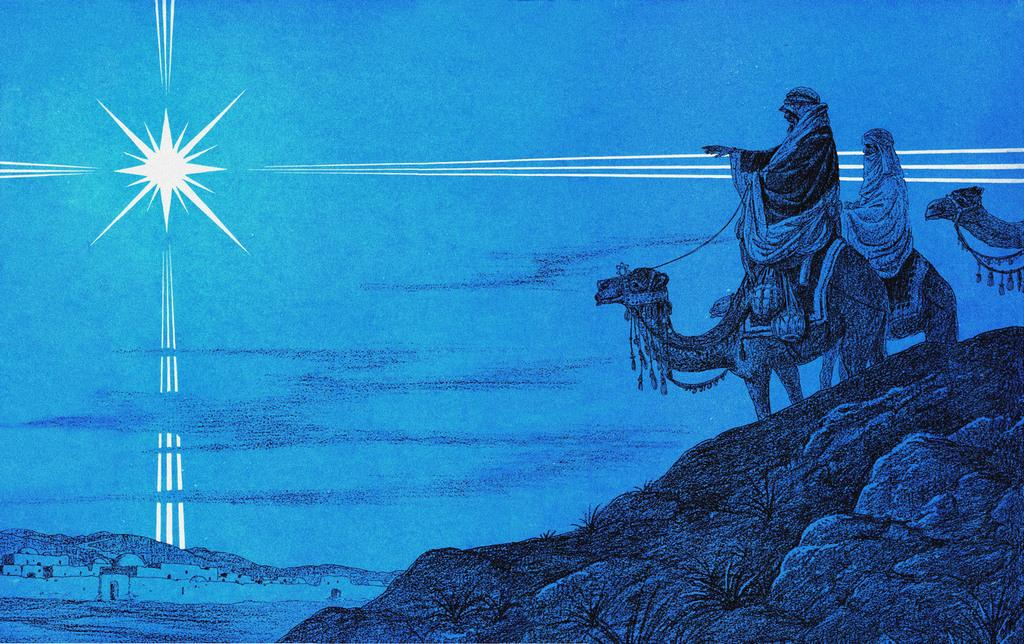What is depicted in the image? The image contains a drawing. What animals are present in the drawing? There are camels in the drawing. Who is riding the camels in the drawing? There are two persons sitting on the camels. What geographical features can be seen in the drawing? There are mountains in the drawing. What type of structures are present in the drawing? There are houses in the drawing. What celestial body is visible in the drawing? There is a sun in the drawing. Can you tell me how many boats are sailing in the drawing? There are no boats present in the drawing; it features camels, persons, mountains, houses, and a sun. What type of wind is blowing in the drawing? There is no mention of wind or a specific type of wind in the drawing; it only shows camels, persons, mountains, houses, and a sun. 